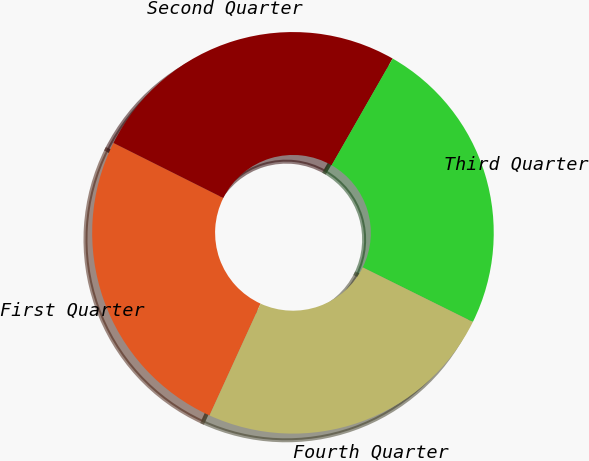Convert chart to OTSL. <chart><loc_0><loc_0><loc_500><loc_500><pie_chart><fcel>First Quarter<fcel>Second Quarter<fcel>Third Quarter<fcel>Fourth Quarter<nl><fcel>25.57%<fcel>25.88%<fcel>24.05%<fcel>24.5%<nl></chart> 